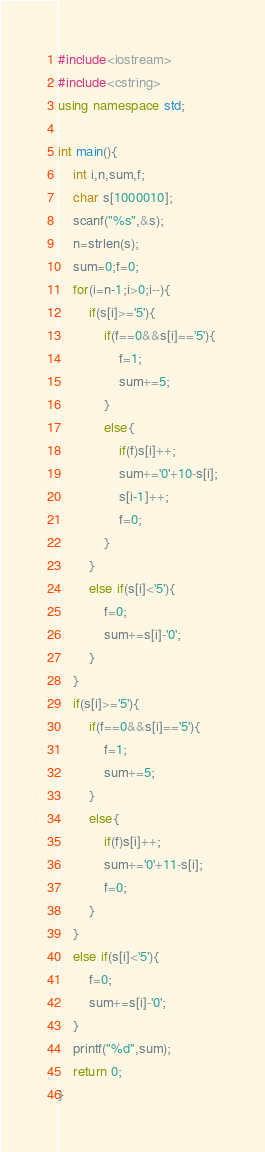<code> <loc_0><loc_0><loc_500><loc_500><_C++_>#include<iostream>
#include<cstring>
using namespace std;

int main(){
	int i,n,sum,f;
	char s[1000010];
	scanf("%s",&s);
	n=strlen(s);
	sum=0;f=0;
	for(i=n-1;i>0;i--){
		if(s[i]>='5'){
			if(f==0&&s[i]=='5'){
				f=1;
				sum+=5;
			}
			else{
				if(f)s[i]++;
				sum+='0'+10-s[i];
				s[i-1]++;
				f=0;
			}
		}
		else if(s[i]<'5'){
			f=0;
			sum+=s[i]-'0';
		}
	}
	if(s[i]>='5'){
		if(f==0&&s[i]=='5'){
			f=1;
			sum+=5;
		}
		else{
			if(f)s[i]++;
			sum+='0'+11-s[i];
			f=0;
		}
	}
	else if(s[i]<'5'){
		f=0;
		sum+=s[i]-'0';
	}
	printf("%d",sum);
	return 0;
}
</code> 